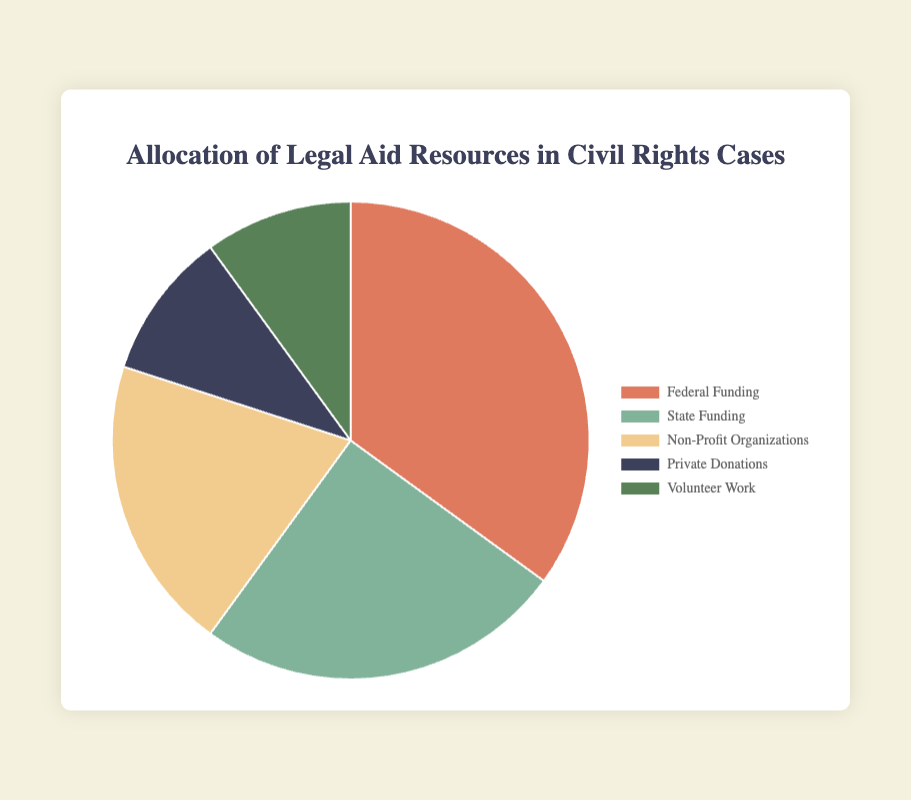Which funding source accounts for the largest percentage in the allocation of legal aid resources? By looking at the chart, the segment with the largest size represents Federal Funding, which is 35% of the total allocation.
Answer: Federal Funding Which two funding sources together make up 45% of the total allocation? By summing up Non-Profit Organizations (20%) and Private Donations (10%), and Volunteer Work (10%), which together make 45%.
Answer: Non-Profit Organizations and Private Donations How does the percentage of State Funding compare to Private Donations? State Funding accounts for 25% and Private Donations account for 10%, so State Funding is significantly higher.
Answer: State Funding is greater What is the combined percentage of federal and state funding in the allocation? Adding the percentages of Federal Funding (35%) and State Funding (25%) results in a total of 60%.
Answer: 60% Which funding sources have the same percentage allocation? Private Donations and Volunteer Work both have an allocation of 10%.
Answer: Private Donations and Volunteer Work How many funding sources contribute at least 20% to the allocation? Federal Funding (35%), State Funding (25%), and Non-Profit Organizations (20%) each contribute at least 20%, summing up to three sources.
Answer: Three What portion of the total allocation is contributed by non-government sources (Non-Profit Organizations, Private Donations, Volunteer Work)? By adding the percentages of Non-Profit Organizations (20%), Private Donations (10%), and Volunteer Work (10%), we obtain 40%.
Answer: 40% What is the difference in allocation percentage between the largest and smallest funding sources? The largest source is Federal Funding at 35% and the smallest sources are Private Donations and Volunteer Work at 10%. The difference is 35% - 10% = 25%.
Answer: 25% 